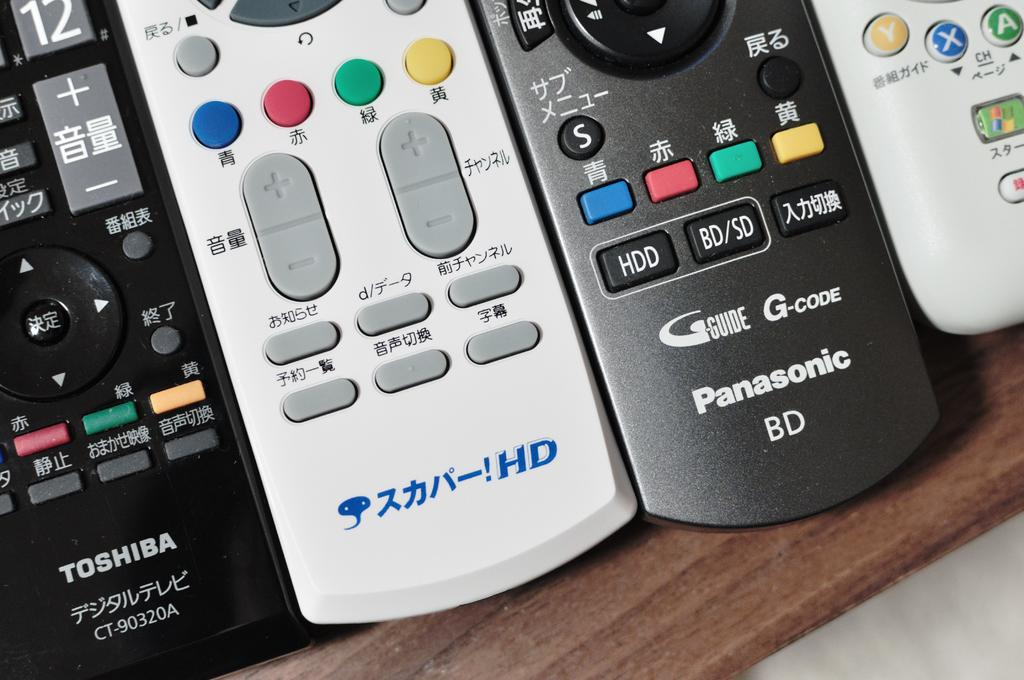<image>
Write a terse but informative summary of the picture. a few remotes, one of which says Panasonic 